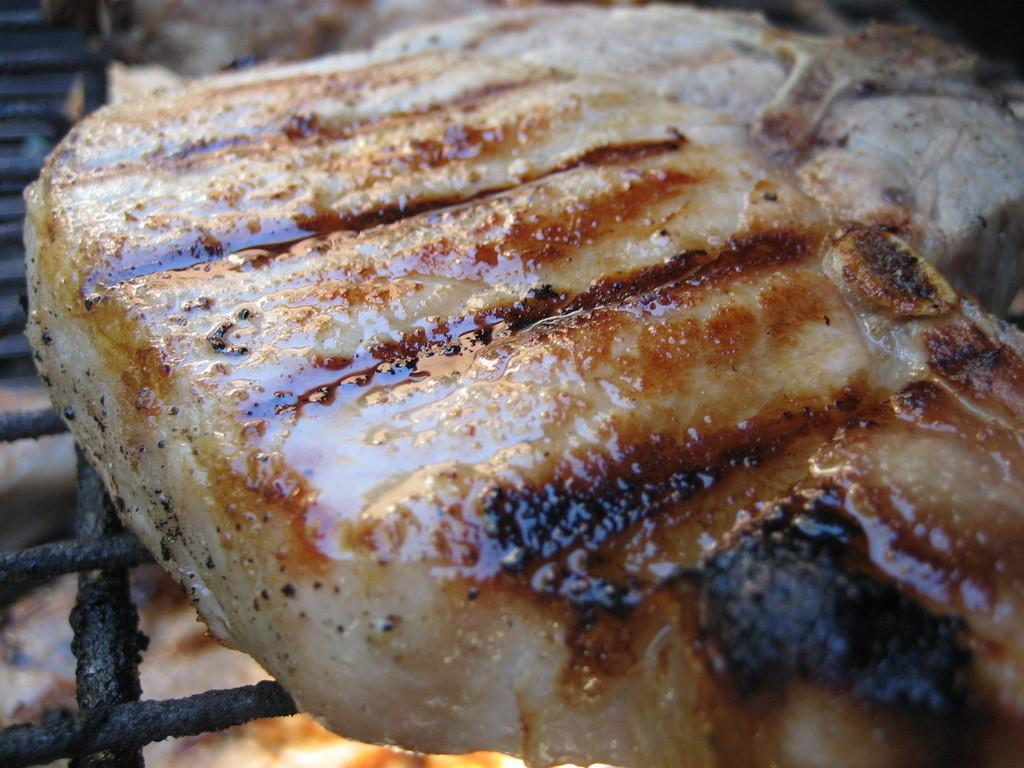What is the main subject of the image? The main subject of the image is food. Where is the food located in the image? The food is on a grill. What type of dress is hanging on the bushes in the image? There are no bushes or dresses present in the image; it features food on a grill. 